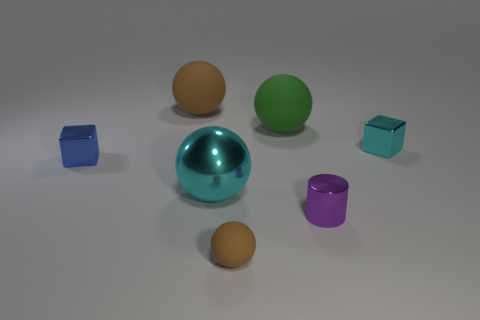What materials appear to be represented in the objects in the image? The image seems to represent various materials. The sphere in the center has a reflective metallic finish, suggestive of a polished metal. The cube to the left and the smaller cube both have a matte texture, possibly representing a plastic material. The other objects, such as the spheres and the cylinder, also have matte surfaces, which hints that they could be made of a similar plastic material. 